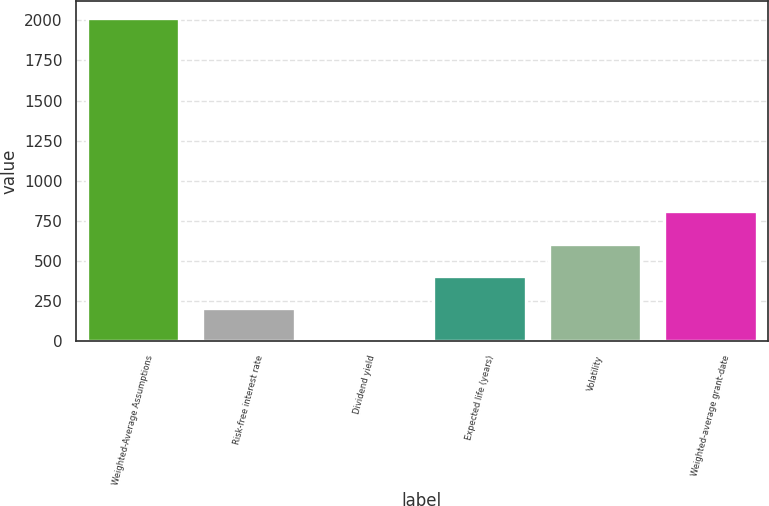Convert chart. <chart><loc_0><loc_0><loc_500><loc_500><bar_chart><fcel>Weighted-Average Assumptions<fcel>Risk-free interest rate<fcel>Dividend yield<fcel>Expected life (years)<fcel>Volatility<fcel>Weighted-average grant-date<nl><fcel>2018<fcel>203.87<fcel>2.3<fcel>405.44<fcel>607.01<fcel>808.58<nl></chart> 